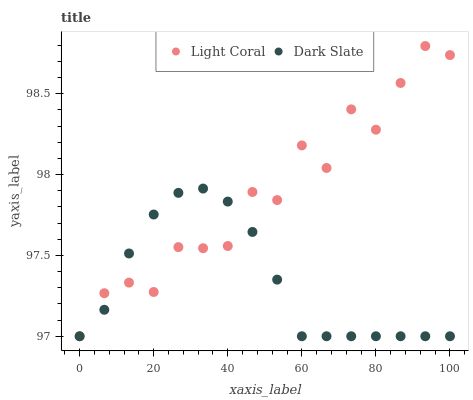Does Dark Slate have the minimum area under the curve?
Answer yes or no. Yes. Does Light Coral have the maximum area under the curve?
Answer yes or no. Yes. Does Dark Slate have the maximum area under the curve?
Answer yes or no. No. Is Dark Slate the smoothest?
Answer yes or no. Yes. Is Light Coral the roughest?
Answer yes or no. Yes. Is Dark Slate the roughest?
Answer yes or no. No. Does Light Coral have the lowest value?
Answer yes or no. Yes. Does Light Coral have the highest value?
Answer yes or no. Yes. Does Dark Slate have the highest value?
Answer yes or no. No. Does Dark Slate intersect Light Coral?
Answer yes or no. Yes. Is Dark Slate less than Light Coral?
Answer yes or no. No. Is Dark Slate greater than Light Coral?
Answer yes or no. No. 